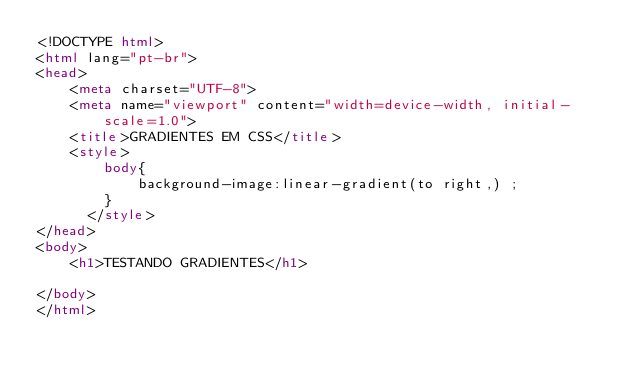<code> <loc_0><loc_0><loc_500><loc_500><_HTML_><!DOCTYPE html>
<html lang="pt-br">
<head>
    <meta charset="UTF-8">
    <meta name="viewport" content="width=device-width, initial-scale=1.0">
    <title>GRADIENTES EM CSS</title>
    <style>
        body{
            background-image:linear-gradient(to right,) ;
        }  
      </style>
</head>
<body>
    <h1>TESTANDO GRADIENTES</h1>
   
</body>
</html>
</code> 